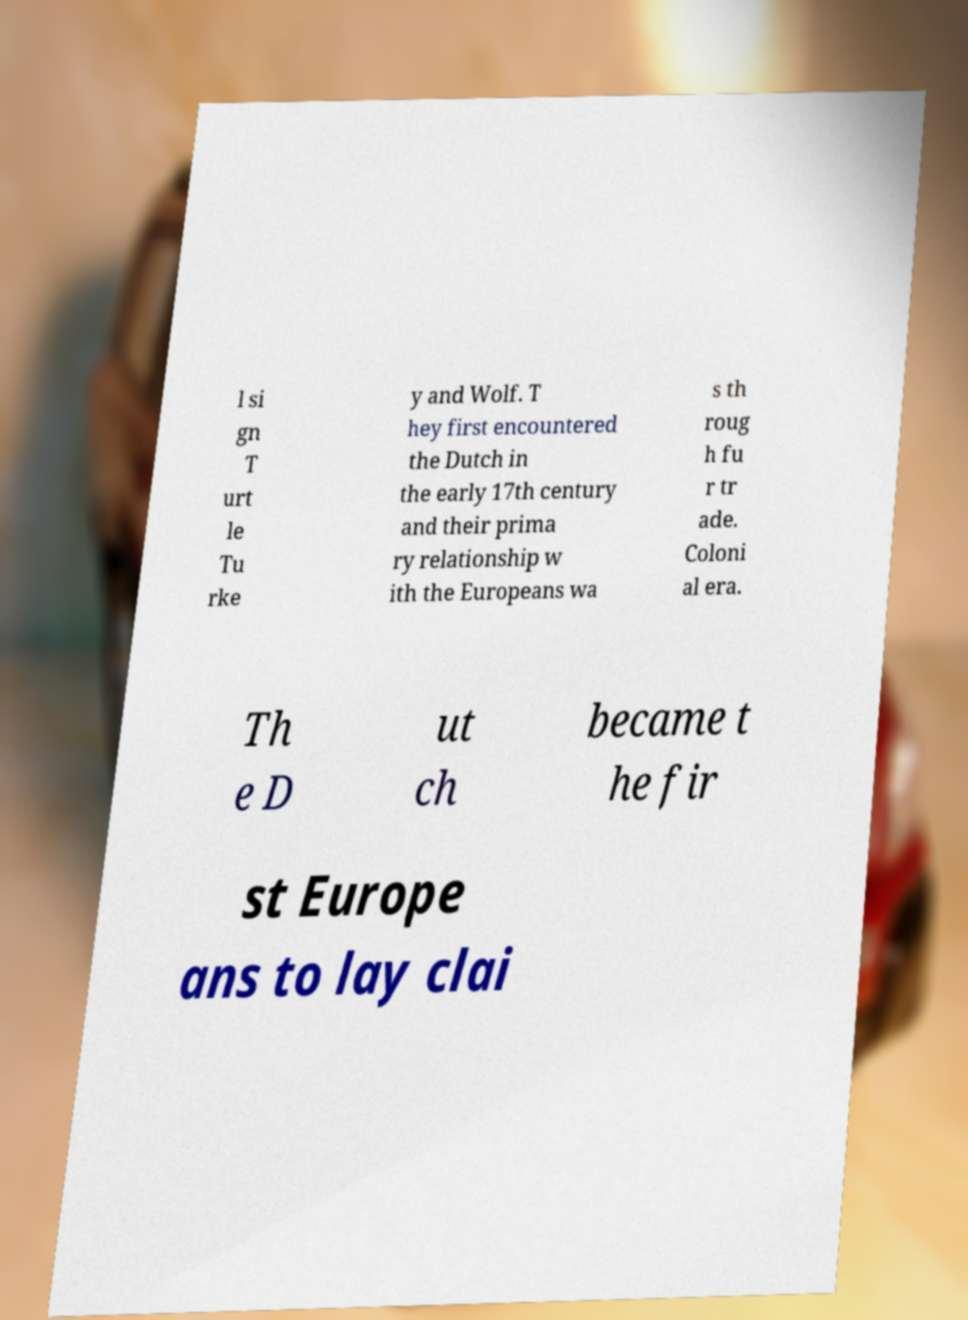Could you extract and type out the text from this image? l si gn T urt le Tu rke y and Wolf. T hey first encountered the Dutch in the early 17th century and their prima ry relationship w ith the Europeans wa s th roug h fu r tr ade. Coloni al era. Th e D ut ch became t he fir st Europe ans to lay clai 